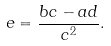Convert formula to latex. <formula><loc_0><loc_0><loc_500><loc_500>e = { \frac { b c - a d } { c ^ { 2 } } } .</formula> 